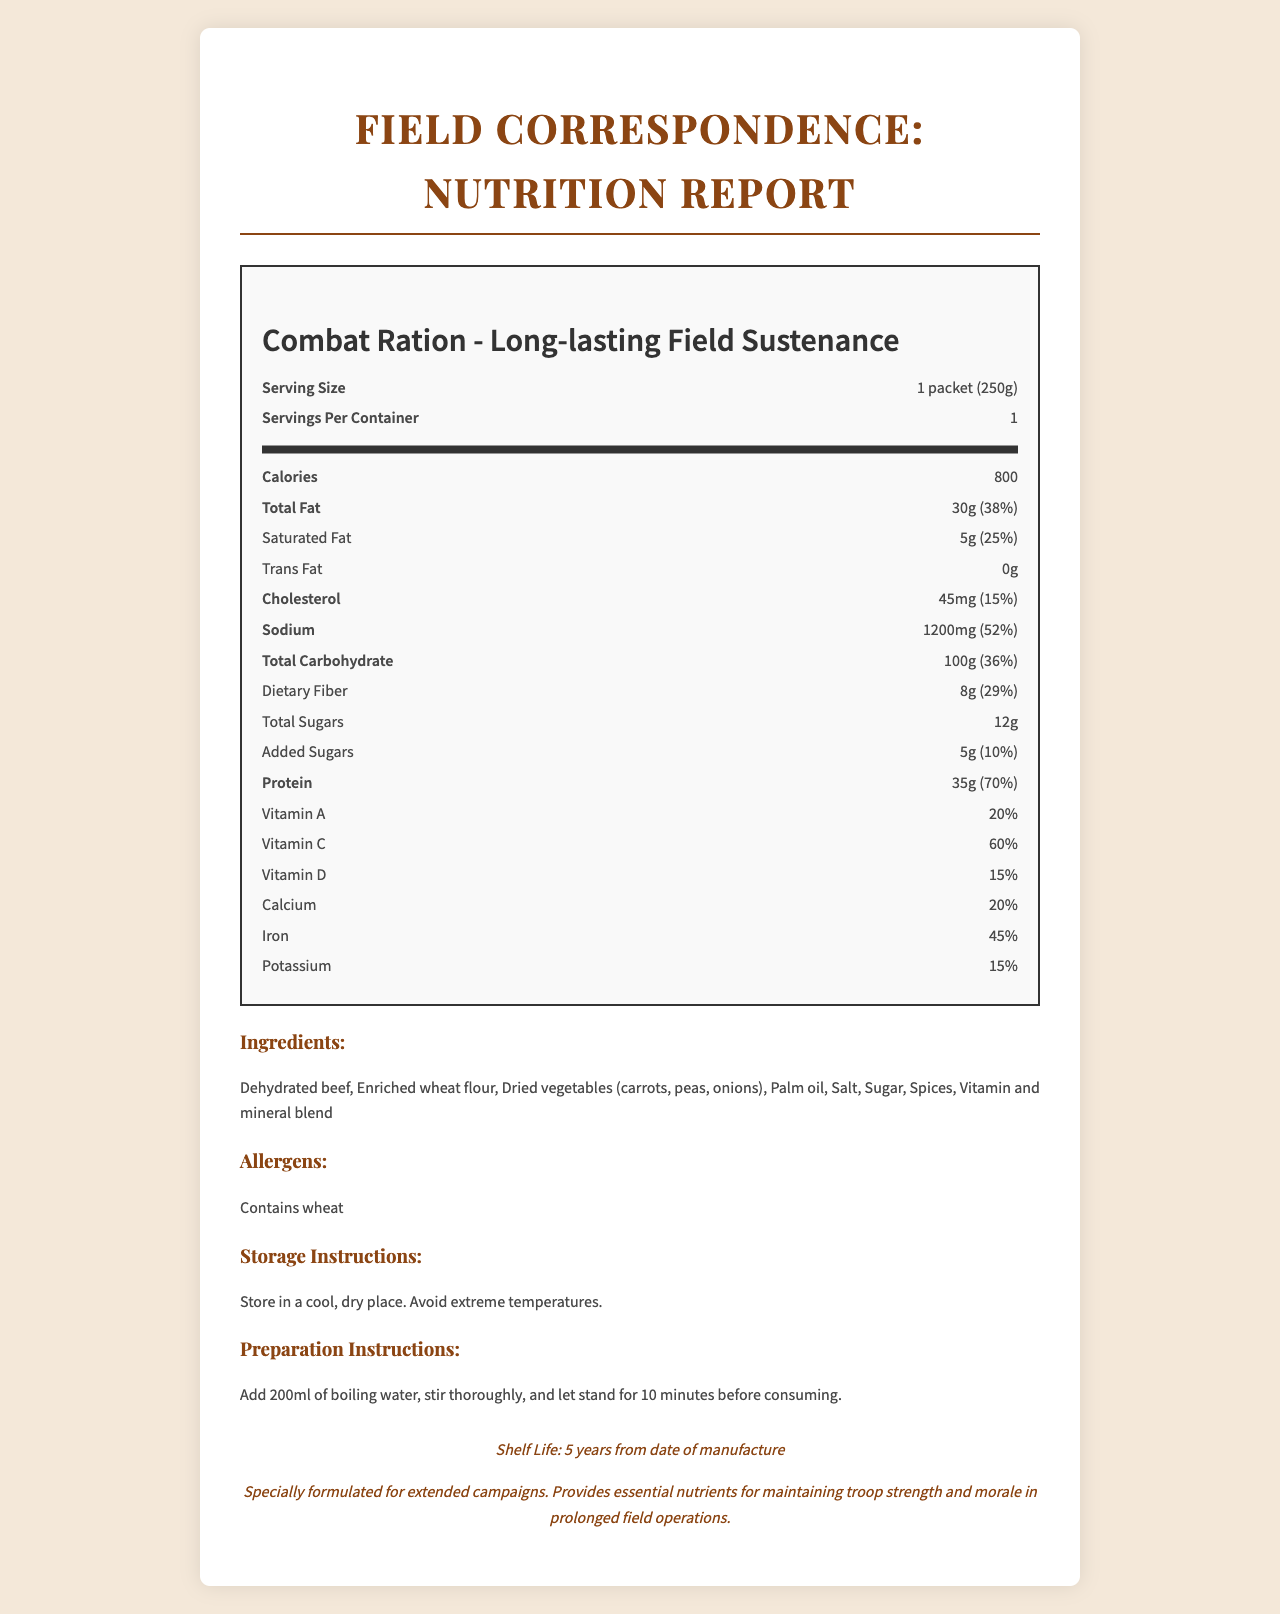what is the serving size of the product? The serving size is clearly stated in the document as "1 packet (250g)".
Answer: 1 packet (250g) how many calories does each serving contain? The document specifies that each serving contains 800 calories.
Answer: 800 what is the percentage daily value of sodium? The nutrition label lists the percent daily value for sodium as 52%.
Answer: 52% name three main ingredients in this product. These ingredients are listed under the "Ingredients" section of the document.
Answer: Dehydrated beef, Enriched wheat flour, Dried vegetables (carrots, peas, onions) how much protein does one serving provide? The document states that one serving provides 35g of protein.
Answer: 35g what is the shelf life of the product? The seal in the document mentions that the shelf life is "5 years from date of manufacture".
Answer: 5 years from date of manufacture how much added sugars are there in one serving? The amount of added sugars per serving is listed as 5g.
Answer: 5g For how long should the product be left to stand after stirring in the boiling water during preparation? The preparation instructions state to let the product stand for 10 minutes after adding boiling water and stirring thoroughly.
Answer: 10 minutes which vitamin is present in the highest percentage daily value? A. Vitamin A B. Vitamin C C. Vitamin D D. Calcium The document indicates that Vitamin C has the highest percent daily value at 60%.
Answer: B how intense is the sodium content compared to other components: Low, Moderate, or High? A. Low B. Moderate C. High The sodium content is high at 52% of the daily value, which is significantly higher compared to other components.
Answer: C does the product contain any trans fat? The nutrition label specifies that the trans fat content is 0g.
Answer: No is the product suitable for someone with a wheat allergy? The document lists "Contains wheat" under the allergens section, indicating it is not suitable for someone with a wheat allergy.
Answer: No provide a brief summary of the main idea of the document. The document provides all essential nutritional and preparatory information regarding the combat ration, which is formulated to maintain troop strength during extended campaigns.
Answer: The document is a detailed nutrition facts label for "Combat Ration - Long-lasting Field Sustenance", designed for use in prolonged field operations. It outlines the serving size, calorie content, and nutritional values, including fat, cholesterol, sodium, carbohydrates, dietary fiber, sugars, protein, and various vitamins and minerals. It also lists the ingredients, allergens, shelf life, storage instructions, and preparation instructions. what is the manufacture date of this product? The document does not provide any information on the manufacture date.
Answer: Cannot be determined 